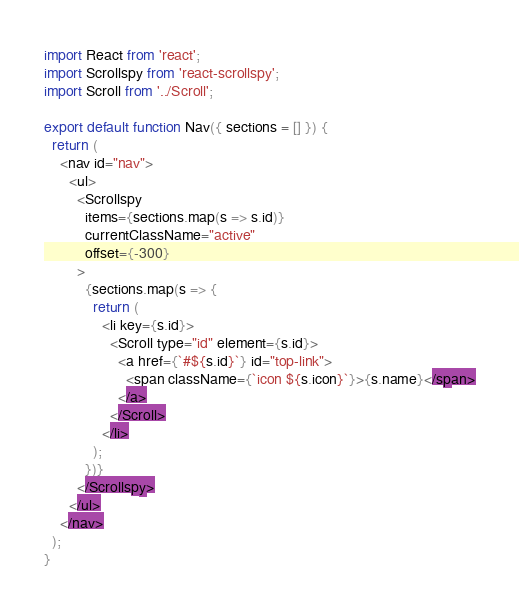Convert code to text. <code><loc_0><loc_0><loc_500><loc_500><_JavaScript_>import React from 'react';
import Scrollspy from 'react-scrollspy';
import Scroll from '../Scroll';

export default function Nav({ sections = [] }) {
  return (
    <nav id="nav">
      <ul>
        <Scrollspy
          items={sections.map(s => s.id)}
          currentClassName="active"
          offset={-300}
        >
          {sections.map(s => {
            return (
              <li key={s.id}>
                <Scroll type="id" element={s.id}>
                  <a href={`#${s.id}`} id="top-link">
                    <span className={`icon ${s.icon}`}>{s.name}</span>
                  </a>
                </Scroll>
              </li>
            );
          })}
        </Scrollspy>
      </ul>
    </nav>
  );
}
</code> 